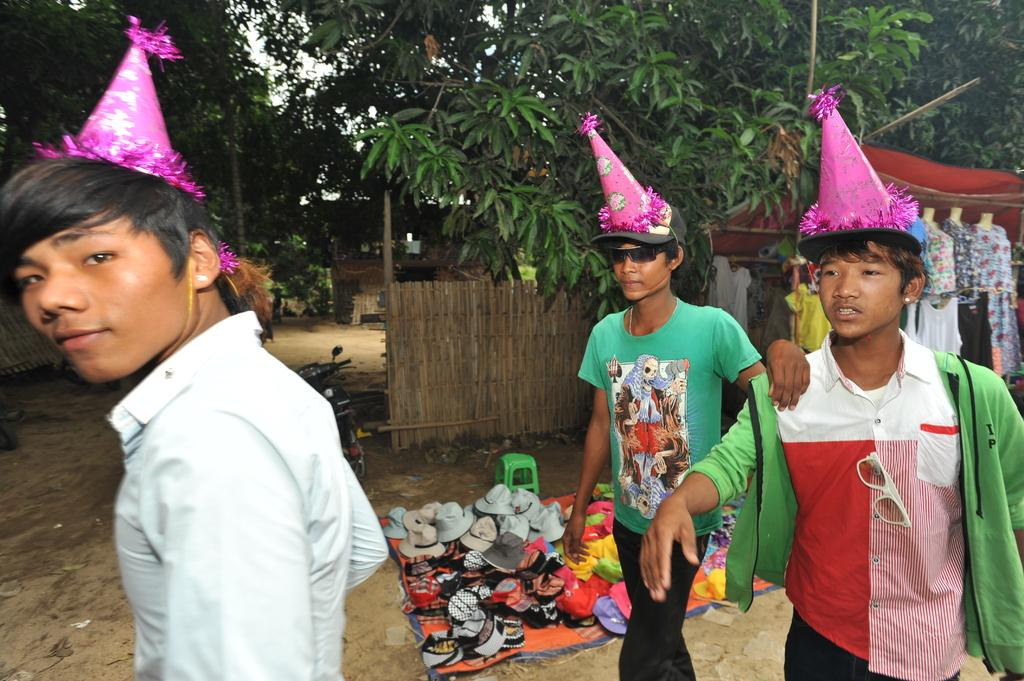What type of headwear can be seen on the men in the image? The men in the image are wearing caps. Are there any other types of headwear visible in the image? Yes, there are hats visible in the image. What can be seen on the ground in the image? The ground is visible in the image. What mode of transportation is present in the image? There is a bike in the image. What type of objects are present in the image that might be used for displaying clothing? Mannequins are present in the image. What type of items can be seen on the mannequins? Clothes are visible in the image. What type of shelter is present in the image? There is a tent and a shed in the image. What type of natural elements can be seen in the image? Trees are present in the image. What is visible in the background of the image? The sky is visible in the background of the image. Can you tell me how many goldfish are swimming in the image? There are no goldfish present in the image. What type of toys can be seen in the image? There are no toys visible in the image. 